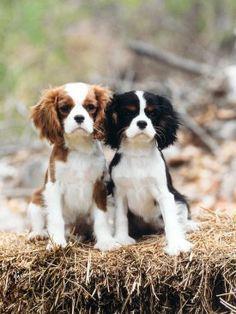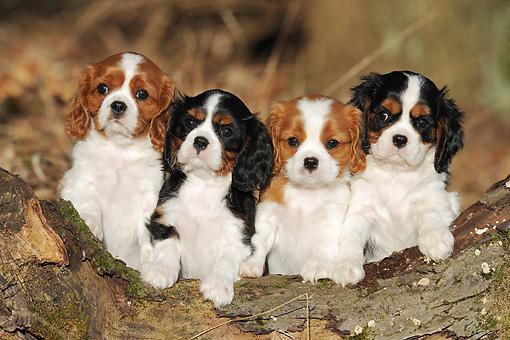The first image is the image on the left, the second image is the image on the right. For the images displayed, is the sentence "At least one image shows one or more Cavalier King Charles Spaniels sitting upright." factually correct? Answer yes or no. Yes. The first image is the image on the left, the second image is the image on the right. For the images shown, is this caption "The image on the left contains twp dogs sitting next to each other." true? Answer yes or no. Yes. 